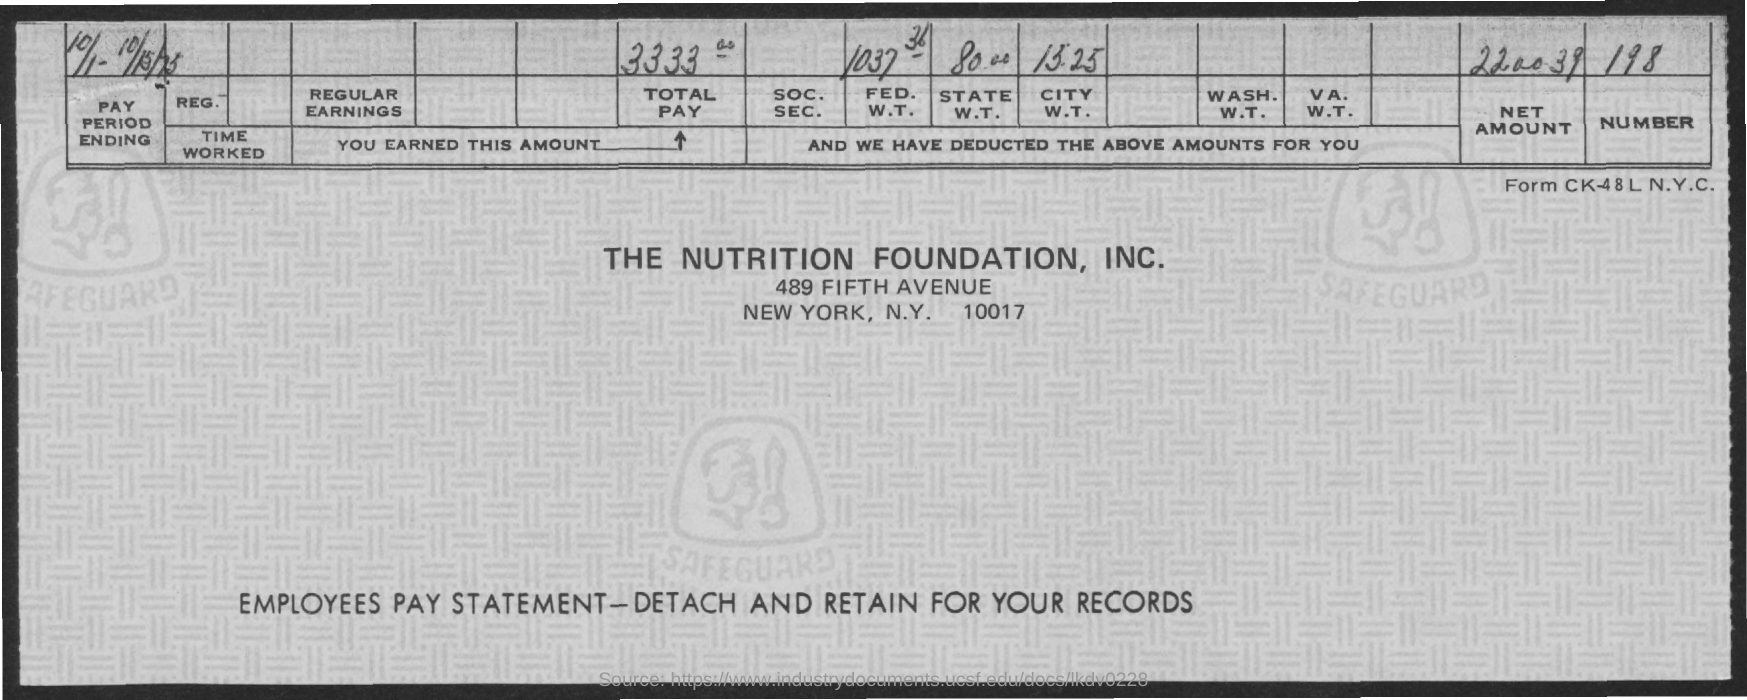Specify some key components in this picture. The total pay is 3333... The net amount is 220039. 